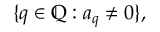<formula> <loc_0><loc_0><loc_500><loc_500>\{ q \in \mathbb { Q } \colon a _ { q } \neq 0 \} ,</formula> 